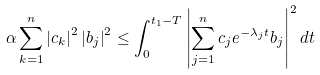Convert formula to latex. <formula><loc_0><loc_0><loc_500><loc_500>\alpha \sum _ { k = 1 } ^ { n } \left | c _ { k } \right | ^ { 2 } \left | b _ { j } \right | ^ { 2 } \leq \int _ { 0 } ^ { t _ { 1 } - T } \left | \sum _ { j = 1 } ^ { n } c _ { j } e ^ { - \lambda _ { j } t } b _ { j } \right | ^ { 2 } d t</formula> 